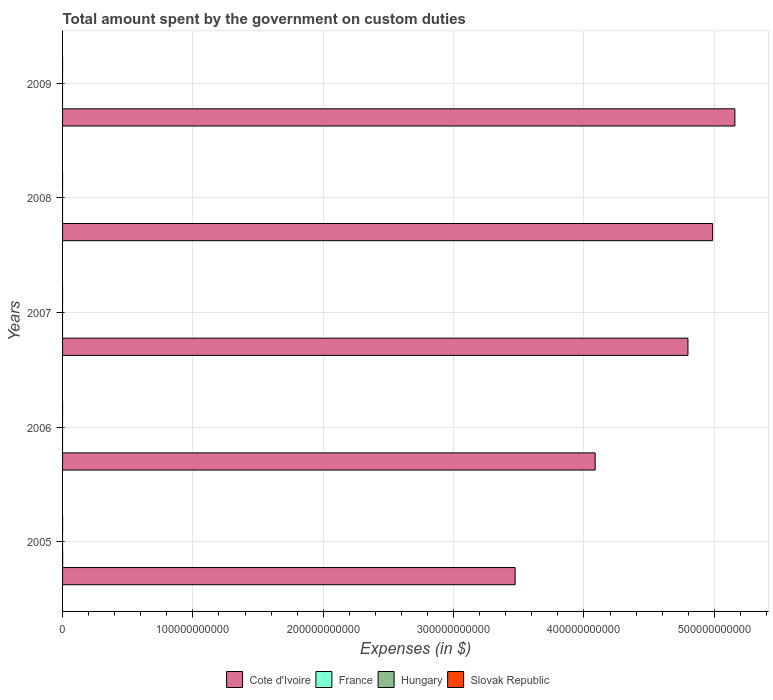How many different coloured bars are there?
Give a very brief answer. 3. How many bars are there on the 4th tick from the bottom?
Give a very brief answer. 2. In how many cases, is the number of bars for a given year not equal to the number of legend labels?
Make the answer very short. 5. What is the amount spent on custom duties by the government in France in 2007?
Provide a short and direct response. 0. Across all years, what is the maximum amount spent on custom duties by the government in Slovak Republic?
Your answer should be very brief. 1.66e+07. Across all years, what is the minimum amount spent on custom duties by the government in Slovak Republic?
Ensure brevity in your answer.  0. In which year was the amount spent on custom duties by the government in France maximum?
Offer a terse response. 2005. What is the total amount spent on custom duties by the government in Slovak Republic in the graph?
Your answer should be very brief. 1.73e+07. What is the difference between the amount spent on custom duties by the government in Cote d'Ivoire in 2005 and that in 2006?
Ensure brevity in your answer.  -6.14e+1. What is the difference between the amount spent on custom duties by the government in Slovak Republic in 2008 and the amount spent on custom duties by the government in France in 2007?
Make the answer very short. 2.90e+04. What is the average amount spent on custom duties by the government in Slovak Republic per year?
Provide a succinct answer. 3.47e+06. In the year 2005, what is the difference between the amount spent on custom duties by the government in Cote d'Ivoire and amount spent on custom duties by the government in France?
Offer a very short reply. 3.47e+11. What is the ratio of the amount spent on custom duties by the government in Cote d'Ivoire in 2008 to that in 2009?
Give a very brief answer. 0.97. What is the difference between the highest and the second highest amount spent on custom duties by the government in Cote d'Ivoire?
Your answer should be very brief. 1.71e+1. What is the difference between the highest and the lowest amount spent on custom duties by the government in Slovak Republic?
Provide a succinct answer. 1.66e+07. Is it the case that in every year, the sum of the amount spent on custom duties by the government in France and amount spent on custom duties by the government in Cote d'Ivoire is greater than the sum of amount spent on custom duties by the government in Slovak Republic and amount spent on custom duties by the government in Hungary?
Give a very brief answer. Yes. Are all the bars in the graph horizontal?
Make the answer very short. Yes. How many years are there in the graph?
Offer a terse response. 5. What is the difference between two consecutive major ticks on the X-axis?
Your response must be concise. 1.00e+11. How are the legend labels stacked?
Offer a very short reply. Horizontal. What is the title of the graph?
Keep it short and to the point. Total amount spent by the government on custom duties. Does "Bhutan" appear as one of the legend labels in the graph?
Offer a terse response. No. What is the label or title of the X-axis?
Offer a very short reply. Expenses (in $). What is the label or title of the Y-axis?
Give a very brief answer. Years. What is the Expenses (in $) of Cote d'Ivoire in 2005?
Ensure brevity in your answer.  3.47e+11. What is the Expenses (in $) in France in 2005?
Provide a succinct answer. 7.30e+07. What is the Expenses (in $) in Hungary in 2005?
Keep it short and to the point. 0. What is the Expenses (in $) in Slovak Republic in 2005?
Your answer should be compact. 1.66e+07. What is the Expenses (in $) of Cote d'Ivoire in 2006?
Provide a short and direct response. 4.09e+11. What is the Expenses (in $) in France in 2006?
Provide a short and direct response. 0. What is the Expenses (in $) in Hungary in 2006?
Give a very brief answer. 0. What is the Expenses (in $) in Cote d'Ivoire in 2007?
Your answer should be compact. 4.80e+11. What is the Expenses (in $) in Hungary in 2007?
Your response must be concise. 0. What is the Expenses (in $) of Slovak Republic in 2007?
Provide a succinct answer. 7.16e+05. What is the Expenses (in $) in Cote d'Ivoire in 2008?
Your response must be concise. 4.99e+11. What is the Expenses (in $) of Slovak Republic in 2008?
Give a very brief answer. 2.90e+04. What is the Expenses (in $) in Cote d'Ivoire in 2009?
Keep it short and to the point. 5.16e+11. What is the Expenses (in $) of France in 2009?
Keep it short and to the point. 0. What is the Expenses (in $) in Hungary in 2009?
Your answer should be very brief. 0. What is the Expenses (in $) of Slovak Republic in 2009?
Your response must be concise. 2.80e+04. Across all years, what is the maximum Expenses (in $) of Cote d'Ivoire?
Provide a succinct answer. 5.16e+11. Across all years, what is the maximum Expenses (in $) in France?
Keep it short and to the point. 7.30e+07. Across all years, what is the maximum Expenses (in $) of Slovak Republic?
Your answer should be compact. 1.66e+07. Across all years, what is the minimum Expenses (in $) of Cote d'Ivoire?
Provide a succinct answer. 3.47e+11. Across all years, what is the minimum Expenses (in $) in Slovak Republic?
Provide a succinct answer. 0. What is the total Expenses (in $) of Cote d'Ivoire in the graph?
Your response must be concise. 2.25e+12. What is the total Expenses (in $) in France in the graph?
Keep it short and to the point. 7.30e+07. What is the total Expenses (in $) in Slovak Republic in the graph?
Ensure brevity in your answer.  1.73e+07. What is the difference between the Expenses (in $) in Cote d'Ivoire in 2005 and that in 2006?
Keep it short and to the point. -6.14e+1. What is the difference between the Expenses (in $) in Cote d'Ivoire in 2005 and that in 2007?
Offer a very short reply. -1.33e+11. What is the difference between the Expenses (in $) of Slovak Republic in 2005 and that in 2007?
Give a very brief answer. 1.58e+07. What is the difference between the Expenses (in $) in Cote d'Ivoire in 2005 and that in 2008?
Make the answer very short. -1.52e+11. What is the difference between the Expenses (in $) of Slovak Republic in 2005 and that in 2008?
Your answer should be compact. 1.65e+07. What is the difference between the Expenses (in $) of Cote d'Ivoire in 2005 and that in 2009?
Your answer should be very brief. -1.69e+11. What is the difference between the Expenses (in $) of Slovak Republic in 2005 and that in 2009?
Keep it short and to the point. 1.65e+07. What is the difference between the Expenses (in $) of Cote d'Ivoire in 2006 and that in 2007?
Give a very brief answer. -7.12e+1. What is the difference between the Expenses (in $) of Cote d'Ivoire in 2006 and that in 2008?
Make the answer very short. -9.01e+1. What is the difference between the Expenses (in $) of Cote d'Ivoire in 2006 and that in 2009?
Give a very brief answer. -1.07e+11. What is the difference between the Expenses (in $) in Cote d'Ivoire in 2007 and that in 2008?
Make the answer very short. -1.89e+1. What is the difference between the Expenses (in $) of Slovak Republic in 2007 and that in 2008?
Your answer should be compact. 6.87e+05. What is the difference between the Expenses (in $) of Cote d'Ivoire in 2007 and that in 2009?
Make the answer very short. -3.60e+1. What is the difference between the Expenses (in $) of Slovak Republic in 2007 and that in 2009?
Your answer should be very brief. 6.88e+05. What is the difference between the Expenses (in $) in Cote d'Ivoire in 2008 and that in 2009?
Your answer should be compact. -1.71e+1. What is the difference between the Expenses (in $) of Slovak Republic in 2008 and that in 2009?
Ensure brevity in your answer.  996.89. What is the difference between the Expenses (in $) of Cote d'Ivoire in 2005 and the Expenses (in $) of Slovak Republic in 2007?
Ensure brevity in your answer.  3.47e+11. What is the difference between the Expenses (in $) of France in 2005 and the Expenses (in $) of Slovak Republic in 2007?
Give a very brief answer. 7.23e+07. What is the difference between the Expenses (in $) in Cote d'Ivoire in 2005 and the Expenses (in $) in Slovak Republic in 2008?
Your answer should be compact. 3.47e+11. What is the difference between the Expenses (in $) in France in 2005 and the Expenses (in $) in Slovak Republic in 2008?
Keep it short and to the point. 7.30e+07. What is the difference between the Expenses (in $) in Cote d'Ivoire in 2005 and the Expenses (in $) in Slovak Republic in 2009?
Your answer should be compact. 3.47e+11. What is the difference between the Expenses (in $) in France in 2005 and the Expenses (in $) in Slovak Republic in 2009?
Your response must be concise. 7.30e+07. What is the difference between the Expenses (in $) in Cote d'Ivoire in 2006 and the Expenses (in $) in Slovak Republic in 2007?
Make the answer very short. 4.09e+11. What is the difference between the Expenses (in $) in Cote d'Ivoire in 2006 and the Expenses (in $) in Slovak Republic in 2008?
Provide a short and direct response. 4.09e+11. What is the difference between the Expenses (in $) of Cote d'Ivoire in 2006 and the Expenses (in $) of Slovak Republic in 2009?
Give a very brief answer. 4.09e+11. What is the difference between the Expenses (in $) in Cote d'Ivoire in 2007 and the Expenses (in $) in Slovak Republic in 2008?
Your response must be concise. 4.80e+11. What is the difference between the Expenses (in $) in Cote d'Ivoire in 2007 and the Expenses (in $) in Slovak Republic in 2009?
Offer a terse response. 4.80e+11. What is the difference between the Expenses (in $) in Cote d'Ivoire in 2008 and the Expenses (in $) in Slovak Republic in 2009?
Keep it short and to the point. 4.99e+11. What is the average Expenses (in $) of Cote d'Ivoire per year?
Provide a succinct answer. 4.50e+11. What is the average Expenses (in $) in France per year?
Your answer should be very brief. 1.46e+07. What is the average Expenses (in $) in Hungary per year?
Your answer should be compact. 0. What is the average Expenses (in $) of Slovak Republic per year?
Offer a very short reply. 3.47e+06. In the year 2005, what is the difference between the Expenses (in $) of Cote d'Ivoire and Expenses (in $) of France?
Your answer should be compact. 3.47e+11. In the year 2005, what is the difference between the Expenses (in $) in Cote d'Ivoire and Expenses (in $) in Slovak Republic?
Your response must be concise. 3.47e+11. In the year 2005, what is the difference between the Expenses (in $) of France and Expenses (in $) of Slovak Republic?
Your answer should be compact. 5.64e+07. In the year 2007, what is the difference between the Expenses (in $) of Cote d'Ivoire and Expenses (in $) of Slovak Republic?
Offer a terse response. 4.80e+11. In the year 2008, what is the difference between the Expenses (in $) in Cote d'Ivoire and Expenses (in $) in Slovak Republic?
Keep it short and to the point. 4.99e+11. In the year 2009, what is the difference between the Expenses (in $) in Cote d'Ivoire and Expenses (in $) in Slovak Republic?
Offer a terse response. 5.16e+11. What is the ratio of the Expenses (in $) in Cote d'Ivoire in 2005 to that in 2006?
Give a very brief answer. 0.85. What is the ratio of the Expenses (in $) of Cote d'Ivoire in 2005 to that in 2007?
Your response must be concise. 0.72. What is the ratio of the Expenses (in $) in Slovak Republic in 2005 to that in 2007?
Provide a succinct answer. 23.13. What is the ratio of the Expenses (in $) of Cote d'Ivoire in 2005 to that in 2008?
Your answer should be very brief. 0.7. What is the ratio of the Expenses (in $) of Slovak Republic in 2005 to that in 2008?
Your answer should be compact. 571.03. What is the ratio of the Expenses (in $) in Cote d'Ivoire in 2005 to that in 2009?
Make the answer very short. 0.67. What is the ratio of the Expenses (in $) of Slovak Republic in 2005 to that in 2009?
Your answer should be compact. 591.35. What is the ratio of the Expenses (in $) of Cote d'Ivoire in 2006 to that in 2007?
Make the answer very short. 0.85. What is the ratio of the Expenses (in $) in Cote d'Ivoire in 2006 to that in 2008?
Offer a very short reply. 0.82. What is the ratio of the Expenses (in $) of Cote d'Ivoire in 2006 to that in 2009?
Offer a terse response. 0.79. What is the ratio of the Expenses (in $) in Cote d'Ivoire in 2007 to that in 2008?
Provide a short and direct response. 0.96. What is the ratio of the Expenses (in $) of Slovak Republic in 2007 to that in 2008?
Your response must be concise. 24.69. What is the ratio of the Expenses (in $) of Cote d'Ivoire in 2007 to that in 2009?
Give a very brief answer. 0.93. What is the ratio of the Expenses (in $) of Slovak Republic in 2007 to that in 2009?
Provide a short and direct response. 25.57. What is the ratio of the Expenses (in $) in Cote d'Ivoire in 2008 to that in 2009?
Offer a terse response. 0.97. What is the ratio of the Expenses (in $) in Slovak Republic in 2008 to that in 2009?
Keep it short and to the point. 1.04. What is the difference between the highest and the second highest Expenses (in $) in Cote d'Ivoire?
Your response must be concise. 1.71e+1. What is the difference between the highest and the second highest Expenses (in $) of Slovak Republic?
Give a very brief answer. 1.58e+07. What is the difference between the highest and the lowest Expenses (in $) of Cote d'Ivoire?
Ensure brevity in your answer.  1.69e+11. What is the difference between the highest and the lowest Expenses (in $) of France?
Provide a short and direct response. 7.30e+07. What is the difference between the highest and the lowest Expenses (in $) of Slovak Republic?
Provide a short and direct response. 1.66e+07. 